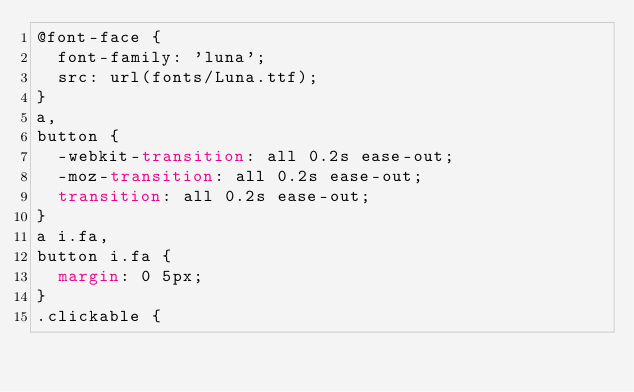<code> <loc_0><loc_0><loc_500><loc_500><_CSS_>@font-face {
  font-family: 'luna';
  src: url(fonts/Luna.ttf);
}
a,
button {
  -webkit-transition: all 0.2s ease-out;
  -moz-transition: all 0.2s ease-out;
  transition: all 0.2s ease-out;
}
a i.fa,
button i.fa {
  margin: 0 5px;
}
.clickable {</code> 